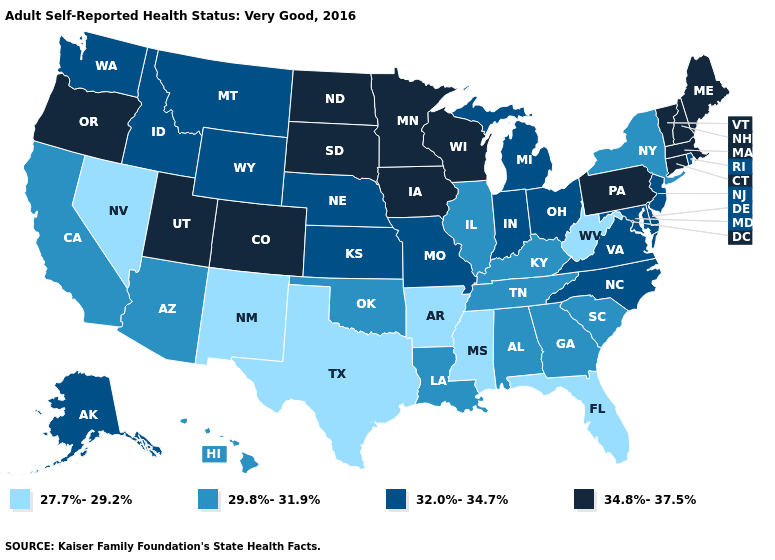Which states have the lowest value in the USA?
Keep it brief. Arkansas, Florida, Mississippi, Nevada, New Mexico, Texas, West Virginia. Does West Virginia have a lower value than Texas?
Be succinct. No. What is the lowest value in states that border Colorado?
Be succinct. 27.7%-29.2%. What is the lowest value in states that border Florida?
Quick response, please. 29.8%-31.9%. Name the states that have a value in the range 29.8%-31.9%?
Be succinct. Alabama, Arizona, California, Georgia, Hawaii, Illinois, Kentucky, Louisiana, New York, Oklahoma, South Carolina, Tennessee. What is the highest value in the South ?
Give a very brief answer. 32.0%-34.7%. Among the states that border Georgia , does Alabama have the lowest value?
Give a very brief answer. No. Name the states that have a value in the range 27.7%-29.2%?
Be succinct. Arkansas, Florida, Mississippi, Nevada, New Mexico, Texas, West Virginia. What is the highest value in the Northeast ?
Be succinct. 34.8%-37.5%. Name the states that have a value in the range 27.7%-29.2%?
Concise answer only. Arkansas, Florida, Mississippi, Nevada, New Mexico, Texas, West Virginia. What is the value of New York?
Be succinct. 29.8%-31.9%. Does Pennsylvania have the lowest value in the USA?
Be succinct. No. Name the states that have a value in the range 34.8%-37.5%?
Short answer required. Colorado, Connecticut, Iowa, Maine, Massachusetts, Minnesota, New Hampshire, North Dakota, Oregon, Pennsylvania, South Dakota, Utah, Vermont, Wisconsin. Which states have the highest value in the USA?
Be succinct. Colorado, Connecticut, Iowa, Maine, Massachusetts, Minnesota, New Hampshire, North Dakota, Oregon, Pennsylvania, South Dakota, Utah, Vermont, Wisconsin. Does the map have missing data?
Short answer required. No. 